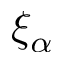<formula> <loc_0><loc_0><loc_500><loc_500>\xi _ { \alpha }</formula> 